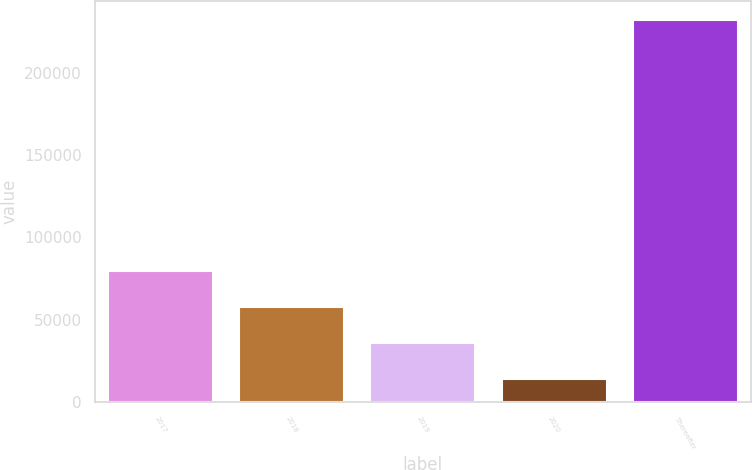Convert chart. <chart><loc_0><loc_0><loc_500><loc_500><bar_chart><fcel>2017<fcel>2018<fcel>2019<fcel>2020<fcel>Thereafter<nl><fcel>79621.9<fcel>57869.6<fcel>36117.3<fcel>14365<fcel>231888<nl></chart> 